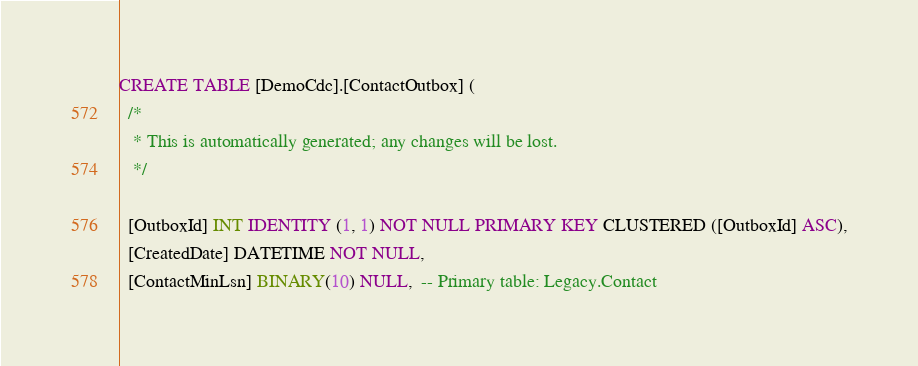Convert code to text. <code><loc_0><loc_0><loc_500><loc_500><_SQL_>CREATE TABLE [DemoCdc].[ContactOutbox] (
  /*
   * This is automatically generated; any changes will be lost.
   */

  [OutboxId] INT IDENTITY (1, 1) NOT NULL PRIMARY KEY CLUSTERED ([OutboxId] ASC),
  [CreatedDate] DATETIME NOT NULL,
  [ContactMinLsn] BINARY(10) NULL,  -- Primary table: Legacy.Contact</code> 